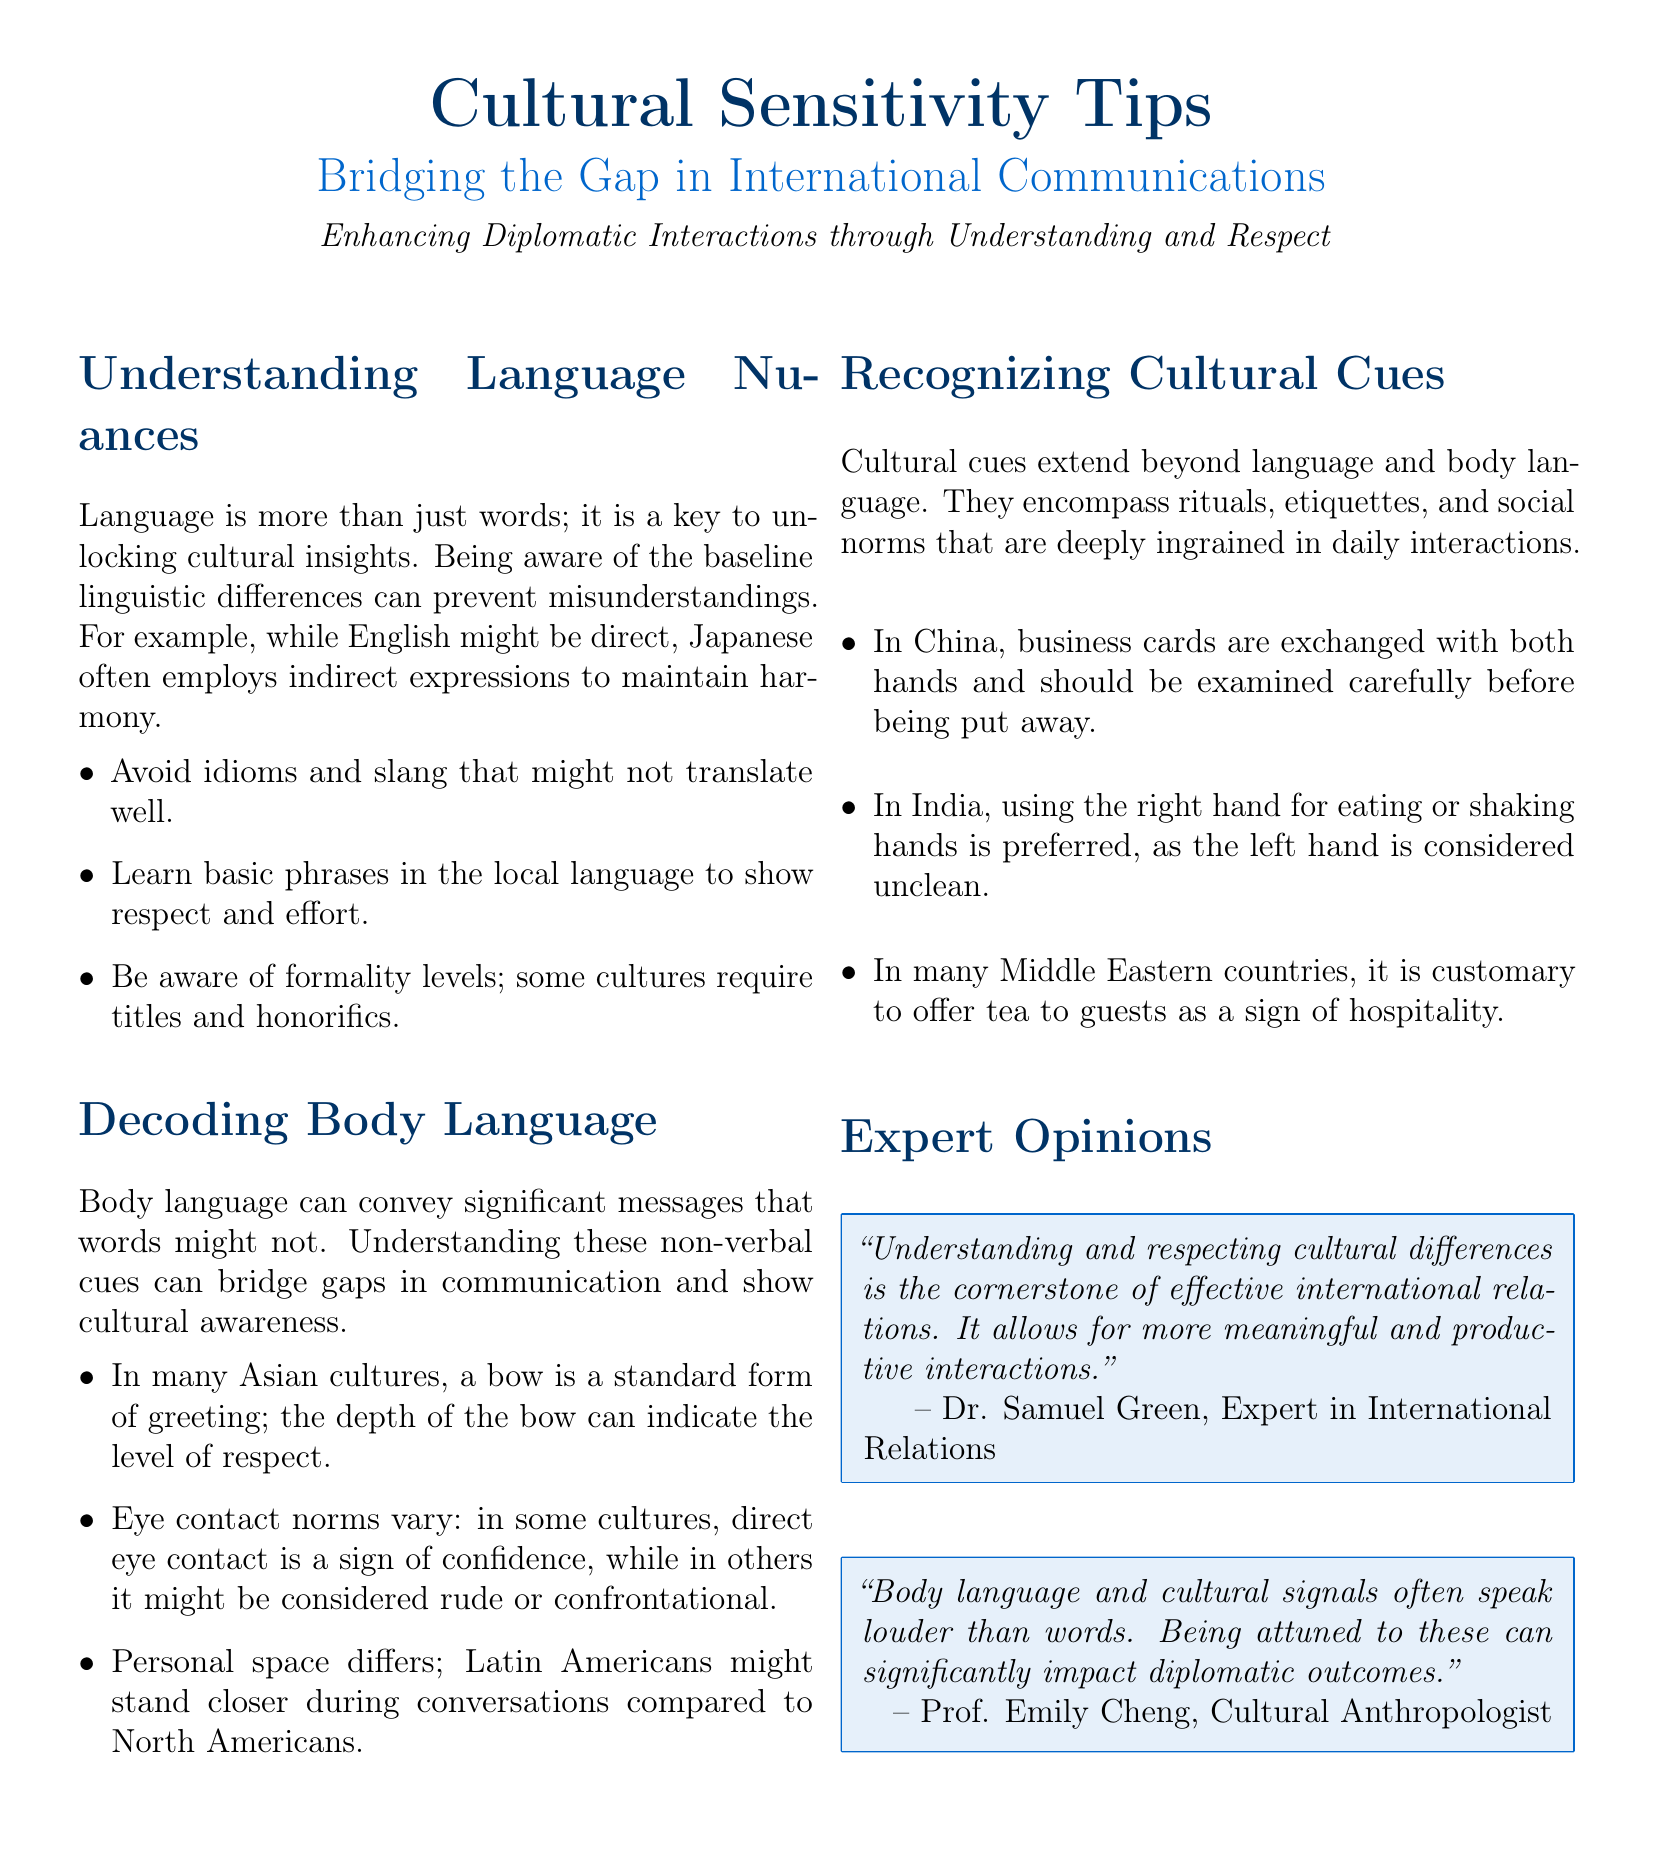What is the title of the section dedicated to practical tips on communication? The section is focused on providing practical tips on communication, indicated as "Cultural Sensitivity Tips: Bridging the Gap in International Communications."
Answer: Cultural Sensitivity Tips: Bridging the Gap in International Communications Who is quoted as an expert in International Relations? The document includes a quote from Dr. Samuel Green, who is labeled an expert in the field of International Relations.
Answer: Dr. Samuel Green In which culture is a bow a standard form of greeting? The document discusses body language norms where a bow is a customary greeting, specifically in many Asian cultures.
Answer: Asian cultures What hand is preferred for eating or shaking hands in India? The document specifies a cultural norm in India regarding the use of hands, indicating that the right hand is preferred.
Answer: Right hand How many tips are provided under "Understanding Language Nuances"? The section lists three specific tips that fall under the understanding of language nuances.
Answer: 3 In which country are business cards exchanged with both hands? The document highlights a cultural practice in China where business cards are exchanged in this manner.
Answer: China What is a customary gesture of hospitality in many Middle Eastern countries? The document mentions offering tea to guests as a sign of hospitality in the context of Middle Eastern cultures.
Answer: Offering tea Which academic discipline does Prof. Emily Cheng belong to? The quote from Prof. Emily Cheng identifies her specialization, which is focused on cultural anthropology.
Answer: Cultural Anthropology 